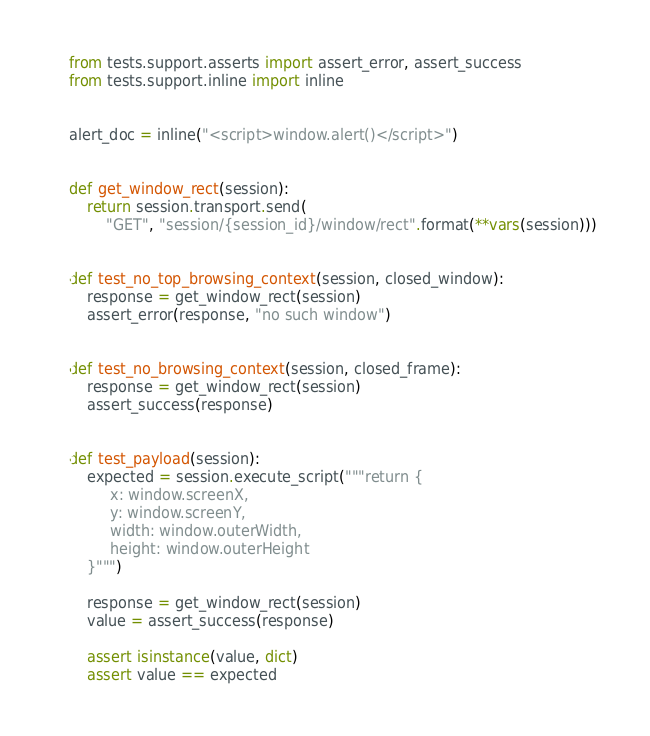<code> <loc_0><loc_0><loc_500><loc_500><_Python_>from tests.support.asserts import assert_error, assert_success
from tests.support.inline import inline


alert_doc = inline("<script>window.alert()</script>")


def get_window_rect(session):
    return session.transport.send(
        "GET", "session/{session_id}/window/rect".format(**vars(session)))


def test_no_top_browsing_context(session, closed_window):
    response = get_window_rect(session)
    assert_error(response, "no such window")


def test_no_browsing_context(session, closed_frame):
    response = get_window_rect(session)
    assert_success(response)


def test_payload(session):
    expected = session.execute_script("""return {
         x: window.screenX,
         y: window.screenY,
         width: window.outerWidth,
         height: window.outerHeight
    }""")

    response = get_window_rect(session)
    value = assert_success(response)

    assert isinstance(value, dict)
    assert value == expected
</code> 